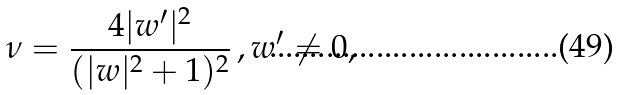<formula> <loc_0><loc_0><loc_500><loc_500>\nu = \frac { 4 | w ^ { \prime } | ^ { 2 } } { ( | w | ^ { 2 } + 1 ) ^ { 2 } } \, , w ^ { \prime } \neq 0 ,</formula> 